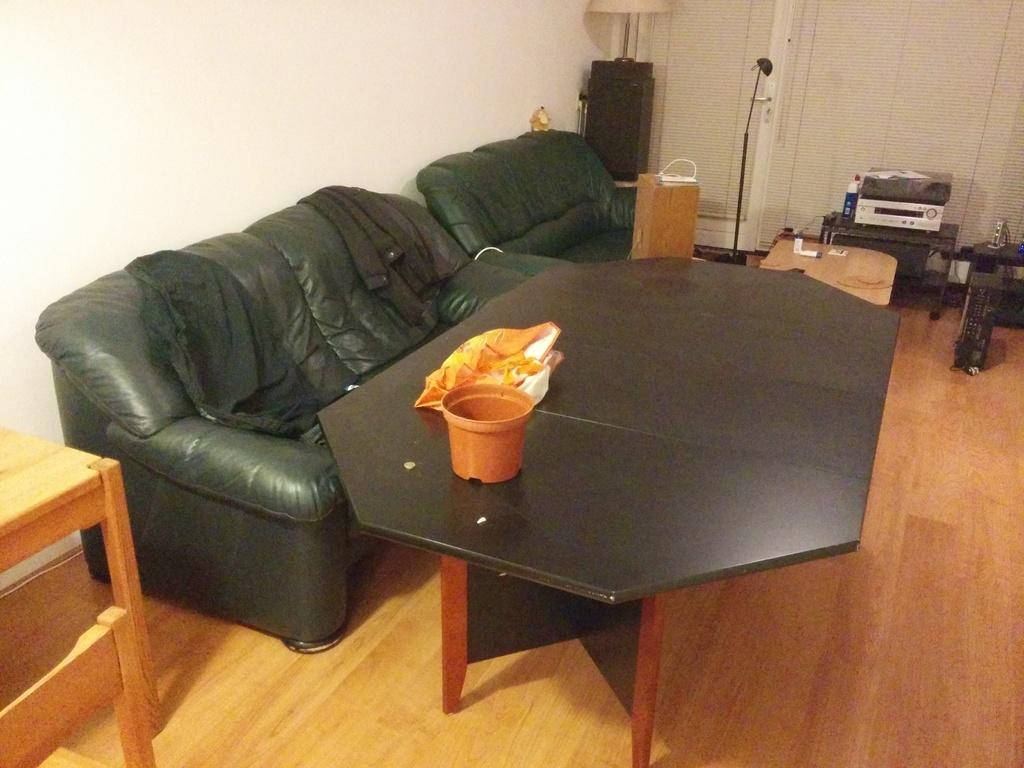What type of furniture is present in the image? There is a couch in the image. What other piece of furniture can be seen in the image? There is a table in the image. What type of items are on the right side of the image? There are electronic products in the image. Can you describe the location of the electronic products in the image? The electronic products are on the right side of the image. What type of finger can be seen in the image? There is no finger present in the image. What type of cow can be seen in the image? There is no cow present in the image. 